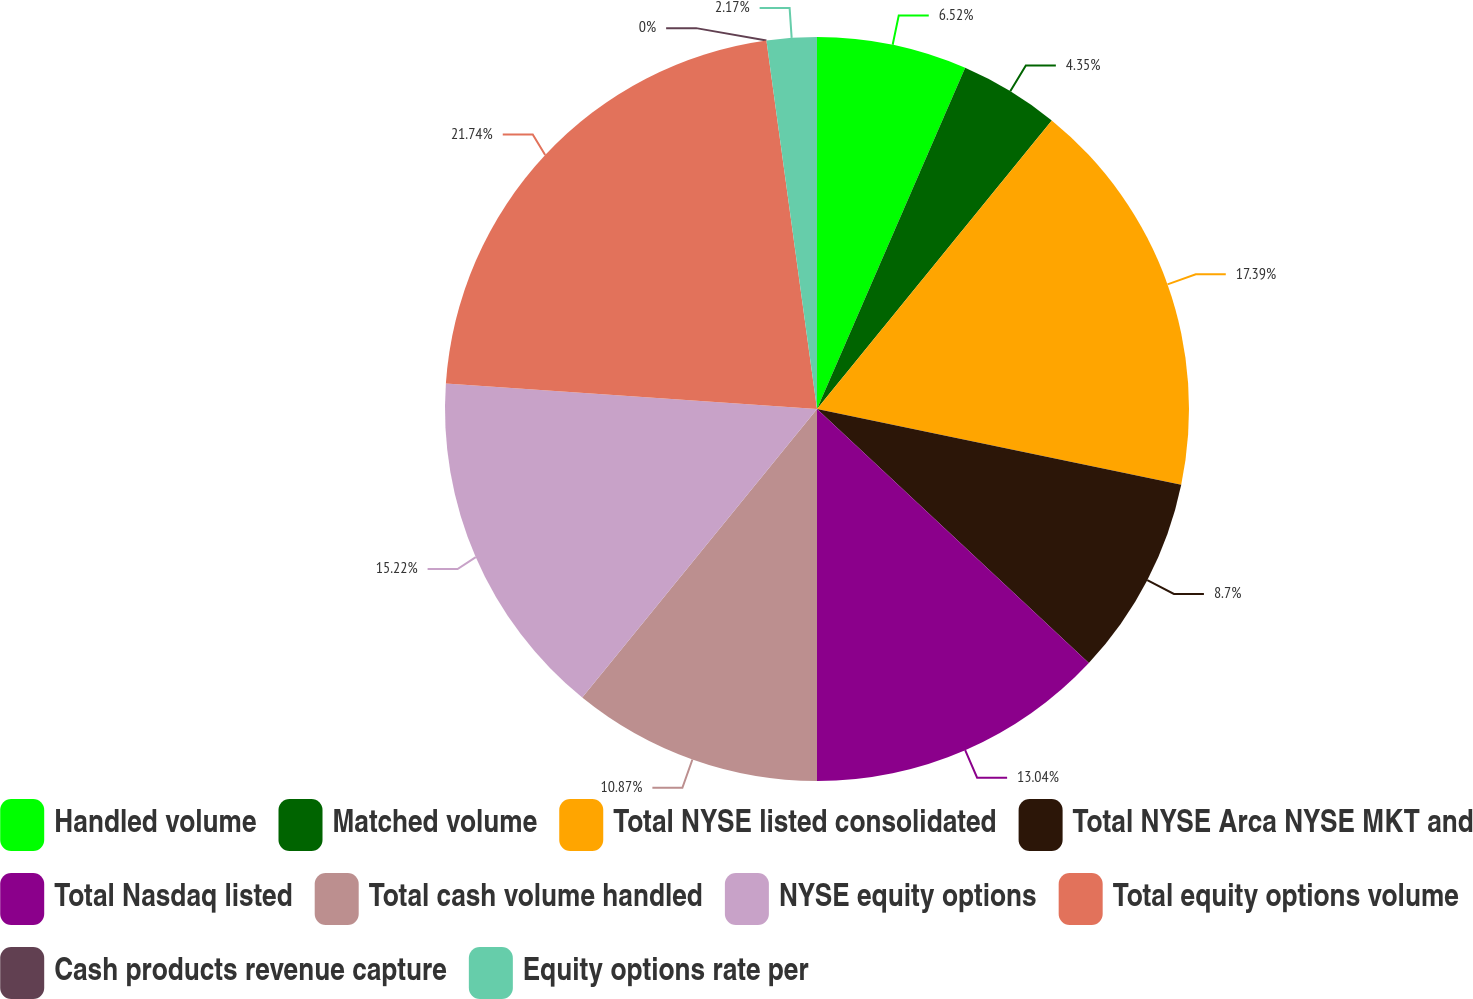Convert chart. <chart><loc_0><loc_0><loc_500><loc_500><pie_chart><fcel>Handled volume<fcel>Matched volume<fcel>Total NYSE listed consolidated<fcel>Total NYSE Arca NYSE MKT and<fcel>Total Nasdaq listed<fcel>Total cash volume handled<fcel>NYSE equity options<fcel>Total equity options volume<fcel>Cash products revenue capture<fcel>Equity options rate per<nl><fcel>6.52%<fcel>4.35%<fcel>17.39%<fcel>8.7%<fcel>13.04%<fcel>10.87%<fcel>15.22%<fcel>21.74%<fcel>0.0%<fcel>2.17%<nl></chart> 